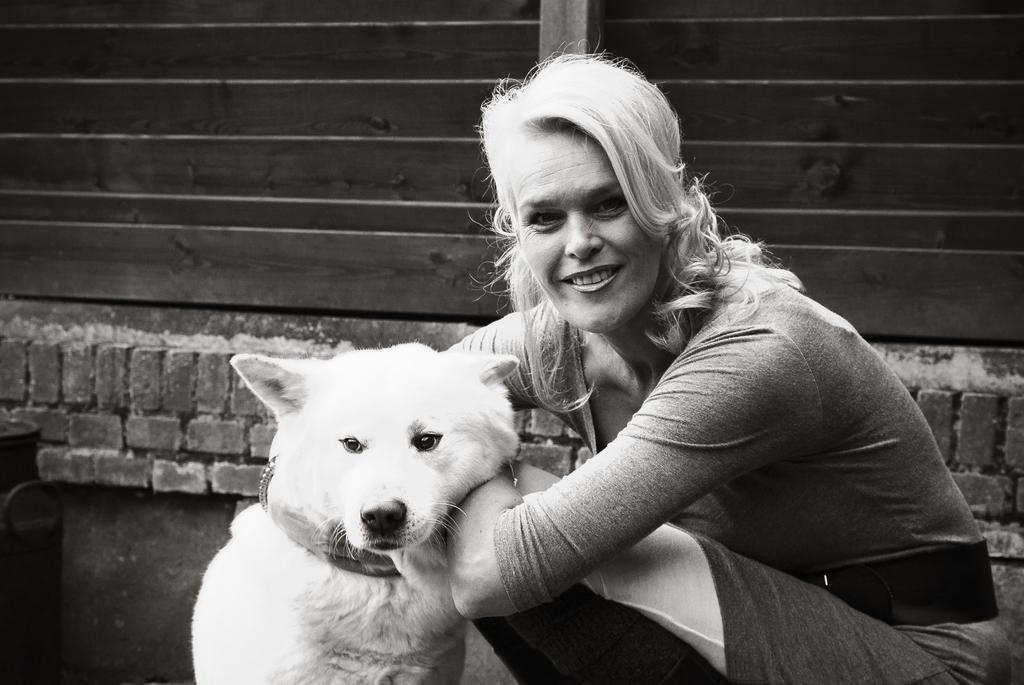Describe this image in one or two sentences. This is a black and white picture. Here is the woman sitting in squat position and smiling. She is holding a dog. This is the dog sitting beside the women. These are the bricks used to construct wall. This looks like a wooden texture background. 